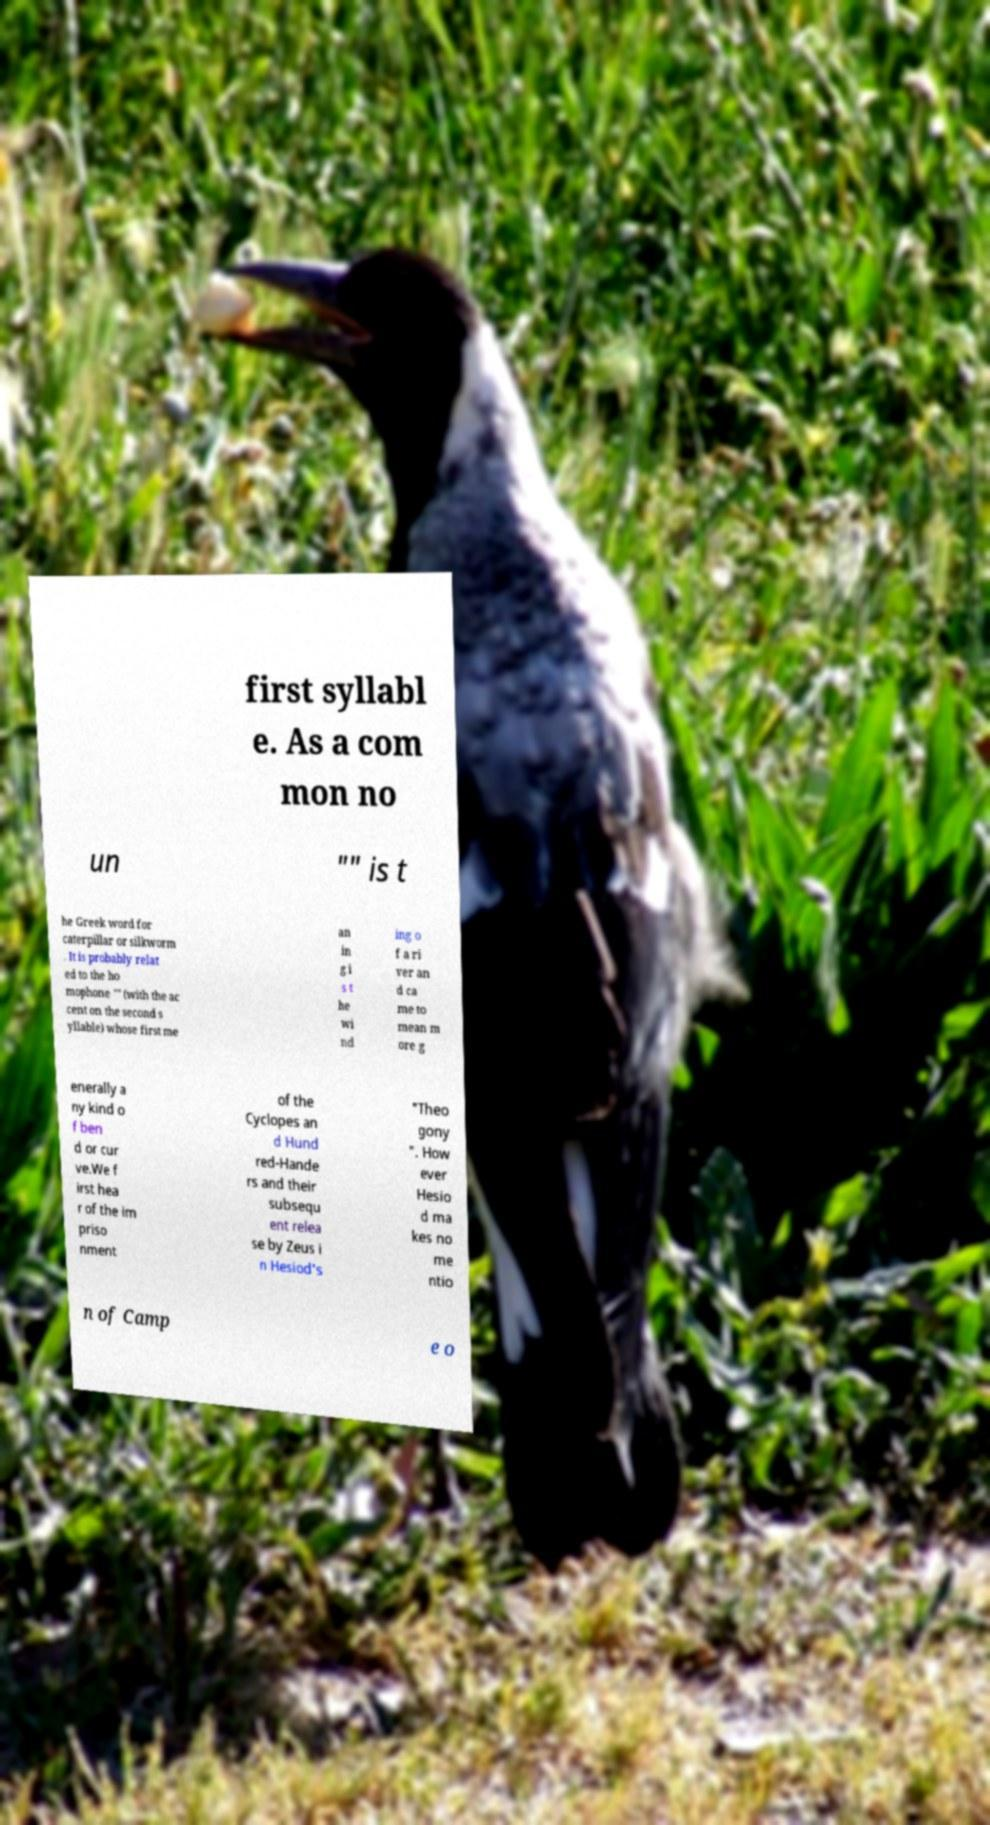For documentation purposes, I need the text within this image transcribed. Could you provide that? first syllabl e. As a com mon no un "" is t he Greek word for caterpillar or silkworm . It is probably relat ed to the ho mophone "" (with the ac cent on the second s yllable) whose first me an in g i s t he wi nd ing o f a ri ver an d ca me to mean m ore g enerally a ny kind o f ben d or cur ve.We f irst hea r of the im priso nment of the Cyclopes an d Hund red-Hande rs and their subsequ ent relea se by Zeus i n Hesiod's "Theo gony ". How ever Hesio d ma kes no me ntio n of Camp e o 